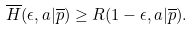<formula> <loc_0><loc_0><loc_500><loc_500>\overline { H } ( \epsilon , a | \overline { p } ) \geq R ( 1 - \epsilon , a | \overline { p } ) .</formula> 